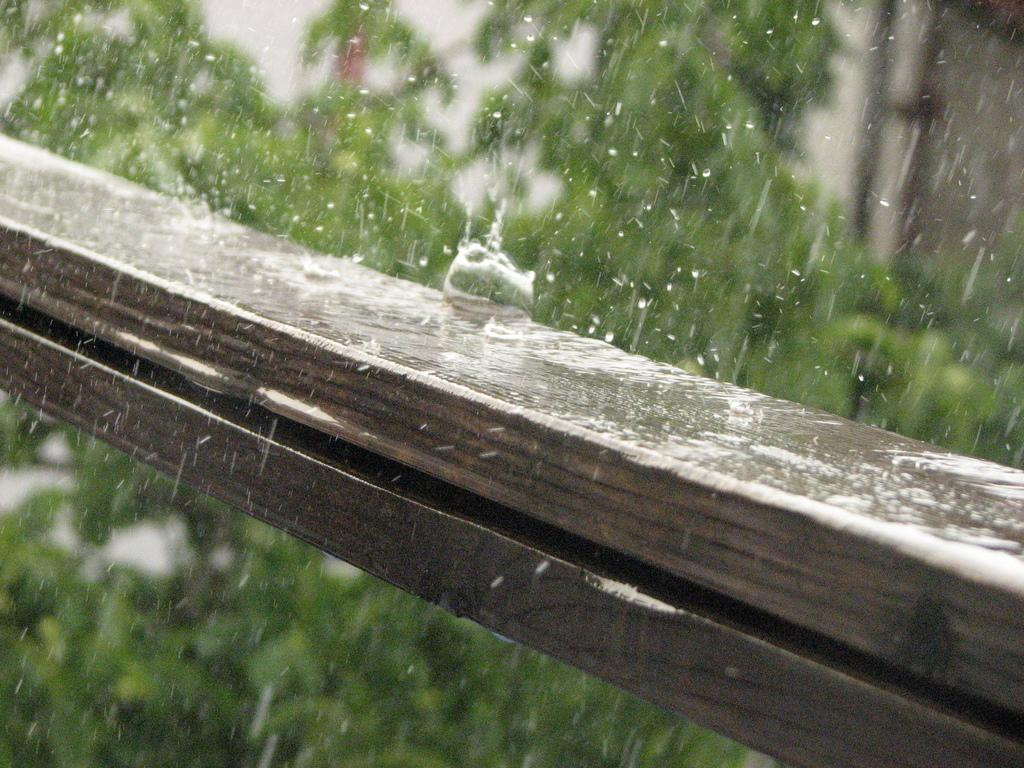What is on the wooden stick in the image? There is rain and water on the wooden stick in the image. What can be seen in the background of the image? There are trees in the background of the image. What type of attack is being launched from the wooden stick in the image? There is no attack being launched from the wooden stick in the image; it is simply a wooden stick with rain and water on it. 